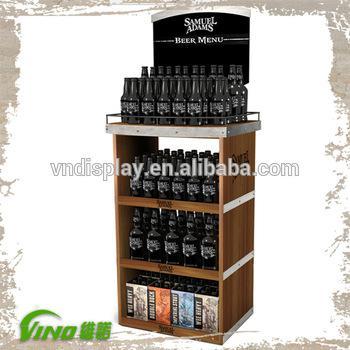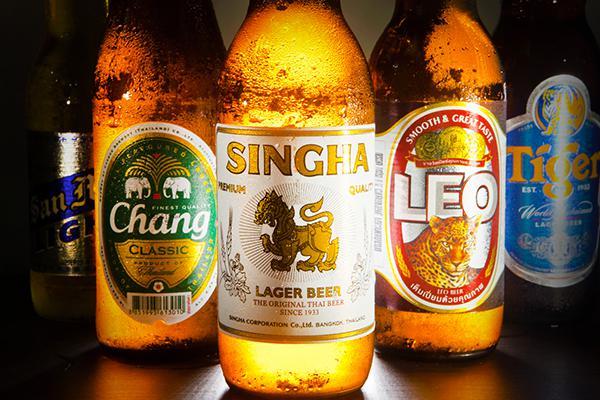The first image is the image on the left, the second image is the image on the right. Examine the images to the left and right. Is the description "All of the beer is on shelving." accurate? Answer yes or no. No. 